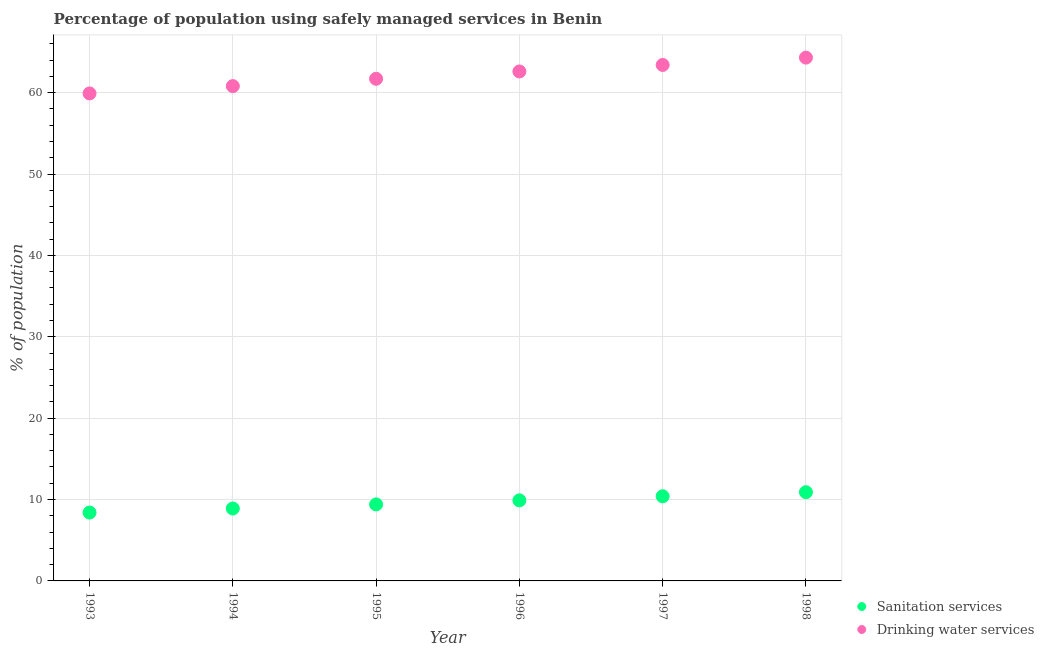What is the percentage of population who used sanitation services in 1998?
Your answer should be compact. 10.9. Across all years, what is the maximum percentage of population who used sanitation services?
Ensure brevity in your answer.  10.9. Across all years, what is the minimum percentage of population who used sanitation services?
Give a very brief answer. 8.4. In which year was the percentage of population who used sanitation services maximum?
Keep it short and to the point. 1998. In which year was the percentage of population who used sanitation services minimum?
Keep it short and to the point. 1993. What is the total percentage of population who used drinking water services in the graph?
Offer a terse response. 372.7. What is the difference between the percentage of population who used drinking water services in 1997 and that in 1998?
Offer a very short reply. -0.9. What is the difference between the percentage of population who used sanitation services in 1996 and the percentage of population who used drinking water services in 1998?
Provide a succinct answer. -54.4. What is the average percentage of population who used sanitation services per year?
Your answer should be very brief. 9.65. In the year 1995, what is the difference between the percentage of population who used sanitation services and percentage of population who used drinking water services?
Provide a succinct answer. -52.3. In how many years, is the percentage of population who used sanitation services greater than 38 %?
Provide a succinct answer. 0. What is the ratio of the percentage of population who used sanitation services in 1997 to that in 1998?
Keep it short and to the point. 0.95. What is the difference between the highest and the lowest percentage of population who used sanitation services?
Give a very brief answer. 2.5. Does the percentage of population who used sanitation services monotonically increase over the years?
Make the answer very short. Yes. How many years are there in the graph?
Your answer should be very brief. 6. What is the difference between two consecutive major ticks on the Y-axis?
Offer a terse response. 10. Are the values on the major ticks of Y-axis written in scientific E-notation?
Your answer should be very brief. No. Where does the legend appear in the graph?
Your response must be concise. Bottom right. How many legend labels are there?
Give a very brief answer. 2. How are the legend labels stacked?
Provide a short and direct response. Vertical. What is the title of the graph?
Offer a terse response. Percentage of population using safely managed services in Benin. Does "Under-5(male)" appear as one of the legend labels in the graph?
Keep it short and to the point. No. What is the label or title of the X-axis?
Ensure brevity in your answer.  Year. What is the label or title of the Y-axis?
Provide a succinct answer. % of population. What is the % of population in Sanitation services in 1993?
Offer a terse response. 8.4. What is the % of population in Drinking water services in 1993?
Make the answer very short. 59.9. What is the % of population in Sanitation services in 1994?
Ensure brevity in your answer.  8.9. What is the % of population in Drinking water services in 1994?
Ensure brevity in your answer.  60.8. What is the % of population in Drinking water services in 1995?
Provide a succinct answer. 61.7. What is the % of population in Sanitation services in 1996?
Make the answer very short. 9.9. What is the % of population of Drinking water services in 1996?
Your answer should be compact. 62.6. What is the % of population in Drinking water services in 1997?
Your answer should be very brief. 63.4. What is the % of population of Drinking water services in 1998?
Your response must be concise. 64.3. Across all years, what is the maximum % of population of Drinking water services?
Provide a succinct answer. 64.3. Across all years, what is the minimum % of population of Sanitation services?
Your answer should be compact. 8.4. Across all years, what is the minimum % of population of Drinking water services?
Offer a terse response. 59.9. What is the total % of population in Sanitation services in the graph?
Provide a short and direct response. 57.9. What is the total % of population of Drinking water services in the graph?
Provide a succinct answer. 372.7. What is the difference between the % of population in Drinking water services in 1993 and that in 1994?
Keep it short and to the point. -0.9. What is the difference between the % of population in Sanitation services in 1993 and that in 1995?
Your response must be concise. -1. What is the difference between the % of population of Drinking water services in 1993 and that in 1995?
Offer a very short reply. -1.8. What is the difference between the % of population of Sanitation services in 1993 and that in 1996?
Provide a short and direct response. -1.5. What is the difference between the % of population in Drinking water services in 1993 and that in 1996?
Give a very brief answer. -2.7. What is the difference between the % of population of Drinking water services in 1993 and that in 1997?
Your answer should be very brief. -3.5. What is the difference between the % of population of Sanitation services in 1993 and that in 1998?
Provide a short and direct response. -2.5. What is the difference between the % of population in Sanitation services in 1994 and that in 1995?
Provide a short and direct response. -0.5. What is the difference between the % of population in Drinking water services in 1994 and that in 1995?
Offer a very short reply. -0.9. What is the difference between the % of population of Sanitation services in 1994 and that in 1997?
Your answer should be compact. -1.5. What is the difference between the % of population of Drinking water services in 1994 and that in 1997?
Provide a short and direct response. -2.6. What is the difference between the % of population in Sanitation services in 1994 and that in 1998?
Provide a succinct answer. -2. What is the difference between the % of population in Drinking water services in 1995 and that in 1997?
Keep it short and to the point. -1.7. What is the difference between the % of population of Sanitation services in 1995 and that in 1998?
Ensure brevity in your answer.  -1.5. What is the difference between the % of population in Drinking water services in 1996 and that in 1997?
Your response must be concise. -0.8. What is the difference between the % of population in Sanitation services in 1996 and that in 1998?
Give a very brief answer. -1. What is the difference between the % of population of Drinking water services in 1996 and that in 1998?
Give a very brief answer. -1.7. What is the difference between the % of population of Sanitation services in 1997 and that in 1998?
Give a very brief answer. -0.5. What is the difference between the % of population of Sanitation services in 1993 and the % of population of Drinking water services in 1994?
Your answer should be very brief. -52.4. What is the difference between the % of population of Sanitation services in 1993 and the % of population of Drinking water services in 1995?
Provide a succinct answer. -53.3. What is the difference between the % of population in Sanitation services in 1993 and the % of population in Drinking water services in 1996?
Your answer should be compact. -54.2. What is the difference between the % of population of Sanitation services in 1993 and the % of population of Drinking water services in 1997?
Provide a short and direct response. -55. What is the difference between the % of population of Sanitation services in 1993 and the % of population of Drinking water services in 1998?
Your answer should be compact. -55.9. What is the difference between the % of population of Sanitation services in 1994 and the % of population of Drinking water services in 1995?
Your answer should be very brief. -52.8. What is the difference between the % of population of Sanitation services in 1994 and the % of population of Drinking water services in 1996?
Offer a very short reply. -53.7. What is the difference between the % of population in Sanitation services in 1994 and the % of population in Drinking water services in 1997?
Your response must be concise. -54.5. What is the difference between the % of population of Sanitation services in 1994 and the % of population of Drinking water services in 1998?
Ensure brevity in your answer.  -55.4. What is the difference between the % of population of Sanitation services in 1995 and the % of population of Drinking water services in 1996?
Make the answer very short. -53.2. What is the difference between the % of population in Sanitation services in 1995 and the % of population in Drinking water services in 1997?
Provide a succinct answer. -54. What is the difference between the % of population of Sanitation services in 1995 and the % of population of Drinking water services in 1998?
Make the answer very short. -54.9. What is the difference between the % of population of Sanitation services in 1996 and the % of population of Drinking water services in 1997?
Offer a terse response. -53.5. What is the difference between the % of population of Sanitation services in 1996 and the % of population of Drinking water services in 1998?
Make the answer very short. -54.4. What is the difference between the % of population of Sanitation services in 1997 and the % of population of Drinking water services in 1998?
Offer a very short reply. -53.9. What is the average % of population of Sanitation services per year?
Your response must be concise. 9.65. What is the average % of population of Drinking water services per year?
Ensure brevity in your answer.  62.12. In the year 1993, what is the difference between the % of population of Sanitation services and % of population of Drinking water services?
Your response must be concise. -51.5. In the year 1994, what is the difference between the % of population in Sanitation services and % of population in Drinking water services?
Provide a succinct answer. -51.9. In the year 1995, what is the difference between the % of population of Sanitation services and % of population of Drinking water services?
Offer a terse response. -52.3. In the year 1996, what is the difference between the % of population in Sanitation services and % of population in Drinking water services?
Your response must be concise. -52.7. In the year 1997, what is the difference between the % of population in Sanitation services and % of population in Drinking water services?
Keep it short and to the point. -53. In the year 1998, what is the difference between the % of population in Sanitation services and % of population in Drinking water services?
Keep it short and to the point. -53.4. What is the ratio of the % of population of Sanitation services in 1993 to that in 1994?
Keep it short and to the point. 0.94. What is the ratio of the % of population of Drinking water services in 1993 to that in 1994?
Your answer should be compact. 0.99. What is the ratio of the % of population in Sanitation services in 1993 to that in 1995?
Offer a very short reply. 0.89. What is the ratio of the % of population of Drinking water services in 1993 to that in 1995?
Provide a succinct answer. 0.97. What is the ratio of the % of population in Sanitation services in 1993 to that in 1996?
Make the answer very short. 0.85. What is the ratio of the % of population of Drinking water services in 1993 to that in 1996?
Keep it short and to the point. 0.96. What is the ratio of the % of population of Sanitation services in 1993 to that in 1997?
Your response must be concise. 0.81. What is the ratio of the % of population in Drinking water services in 1993 to that in 1997?
Make the answer very short. 0.94. What is the ratio of the % of population in Sanitation services in 1993 to that in 1998?
Provide a short and direct response. 0.77. What is the ratio of the % of population of Drinking water services in 1993 to that in 1998?
Give a very brief answer. 0.93. What is the ratio of the % of population in Sanitation services in 1994 to that in 1995?
Offer a very short reply. 0.95. What is the ratio of the % of population of Drinking water services in 1994 to that in 1995?
Give a very brief answer. 0.99. What is the ratio of the % of population of Sanitation services in 1994 to that in 1996?
Offer a very short reply. 0.9. What is the ratio of the % of population in Drinking water services in 1994 to that in 1996?
Make the answer very short. 0.97. What is the ratio of the % of population of Sanitation services in 1994 to that in 1997?
Your answer should be compact. 0.86. What is the ratio of the % of population of Drinking water services in 1994 to that in 1997?
Provide a succinct answer. 0.96. What is the ratio of the % of population in Sanitation services in 1994 to that in 1998?
Ensure brevity in your answer.  0.82. What is the ratio of the % of population of Drinking water services in 1994 to that in 1998?
Provide a short and direct response. 0.95. What is the ratio of the % of population in Sanitation services in 1995 to that in 1996?
Your answer should be very brief. 0.95. What is the ratio of the % of population in Drinking water services in 1995 to that in 1996?
Your response must be concise. 0.99. What is the ratio of the % of population in Sanitation services in 1995 to that in 1997?
Keep it short and to the point. 0.9. What is the ratio of the % of population in Drinking water services in 1995 to that in 1997?
Offer a very short reply. 0.97. What is the ratio of the % of population in Sanitation services in 1995 to that in 1998?
Provide a short and direct response. 0.86. What is the ratio of the % of population of Drinking water services in 1995 to that in 1998?
Your response must be concise. 0.96. What is the ratio of the % of population in Sanitation services in 1996 to that in 1997?
Make the answer very short. 0.95. What is the ratio of the % of population in Drinking water services in 1996 to that in 1997?
Make the answer very short. 0.99. What is the ratio of the % of population in Sanitation services in 1996 to that in 1998?
Offer a very short reply. 0.91. What is the ratio of the % of population in Drinking water services in 1996 to that in 1998?
Your response must be concise. 0.97. What is the ratio of the % of population of Sanitation services in 1997 to that in 1998?
Your answer should be compact. 0.95. What is the ratio of the % of population of Drinking water services in 1997 to that in 1998?
Offer a terse response. 0.99. What is the difference between the highest and the second highest % of population in Drinking water services?
Provide a succinct answer. 0.9. 